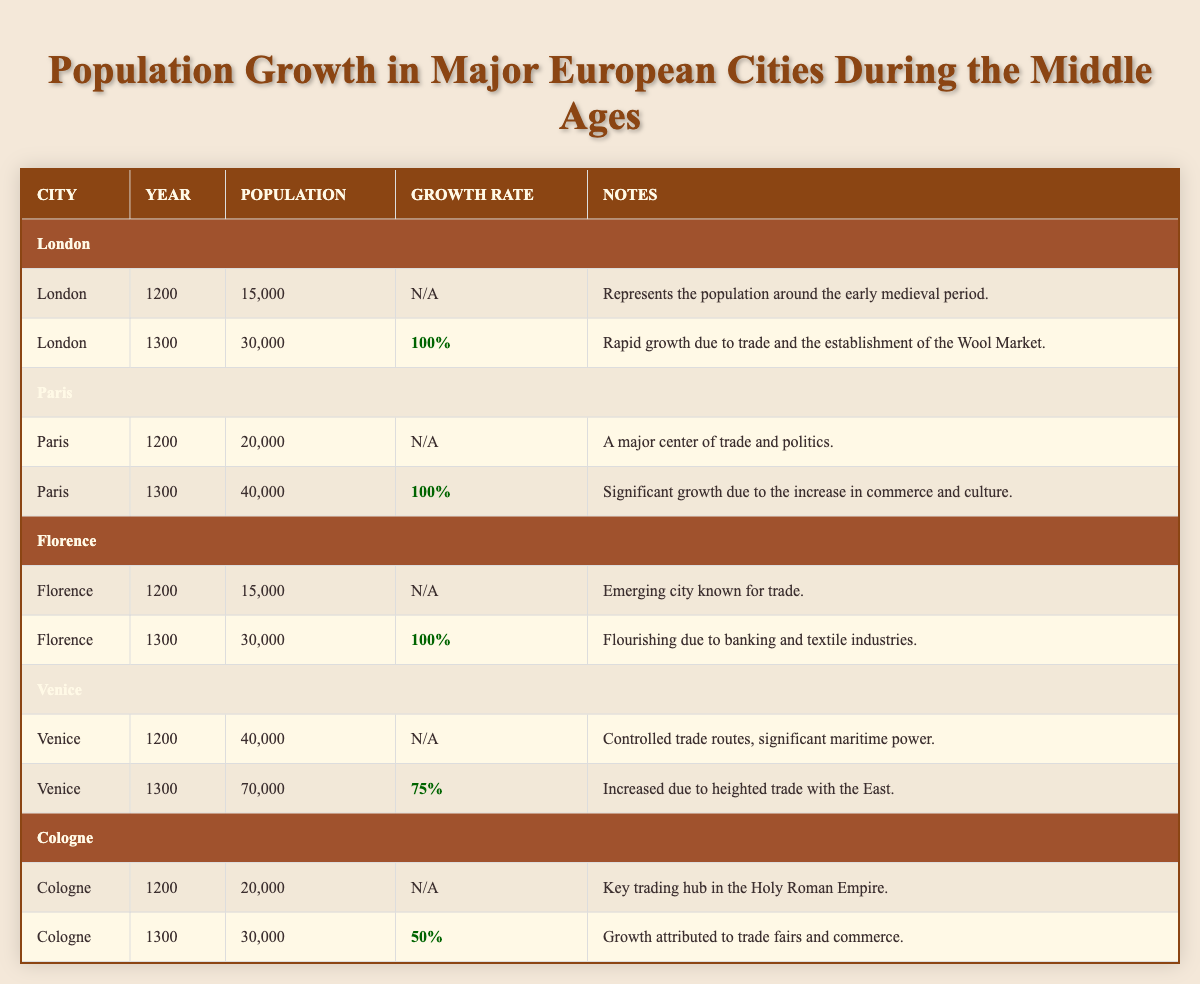What was the population of London in the year 1300? According to the table, London had a population of 30,000 in the year 1300. The specific row for London under the year 1300 mentions this exact number.
Answer: 30,000 What is the growth rate for population in Venice from 1200 to 1300? The table indicates that Venice's population grew from 40,000 in 1200 to 70,000 in 1300. The growth rate is calculated by taking the difference (70,000 - 40,000 = 30,000), dividing by the original population (30,000 / 40,000 = 0.75), and converting to a percentage (0.75 x 100 = 75%).
Answer: 75% Was the population of Florence greater than that of Cologne in the year 1200? From the table, Florence had a population of 15,000 while Cologne had 20,000. Since 15,000 is less than 20,000, the answer is no.
Answer: No Which city had the highest population growth rate from 1200 to 1300? First, consider the growth rates: London had 100%, Paris 100%, Florence 100%, Venice 75%, and Cologne 50%. The maximum among these is 100%. Therefore, London, Paris, and Florence all share the highest growth rate.
Answer: London, Paris, Florence What was the total population of all cities listed in the year 1300? The populations for all cities in 1300 are: London (30,000), Paris (40,000), Florence (30,000), Venice (70,000), and Cologne (30,000). Summing these gives 30,000 + 40,000 + 30,000 + 70,000 + 30,000 = 200,000 total.
Answer: 200,000 Did Cologne experience a growth rate greater than Venice from 1200 to 1300? Cologne grew from 20,000 to 30,000, which is a growth of 50%. Venice grew from 40,000 to 70,000, which is a growth of 75%. Since 75% is greater than 50%, the answer is no.
Answer: No What was the population of Paris in the year 1200? The table states that Paris had a population of 20,000 in the year 1200, as indicated in the corresponding row for Paris under that year.
Answer: 20,000 How many cities had a growth rate of 100% during the specified period? From the data, London, Paris, and Florence each had a growth rate of 100%. Counting these, there are three cities that meet this criterion.
Answer: 3 